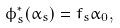Convert formula to latex. <formula><loc_0><loc_0><loc_500><loc_500>\phi _ { s } ^ { * } ( \alpha _ { s } ) = f _ { s } \alpha _ { 0 } ,</formula> 